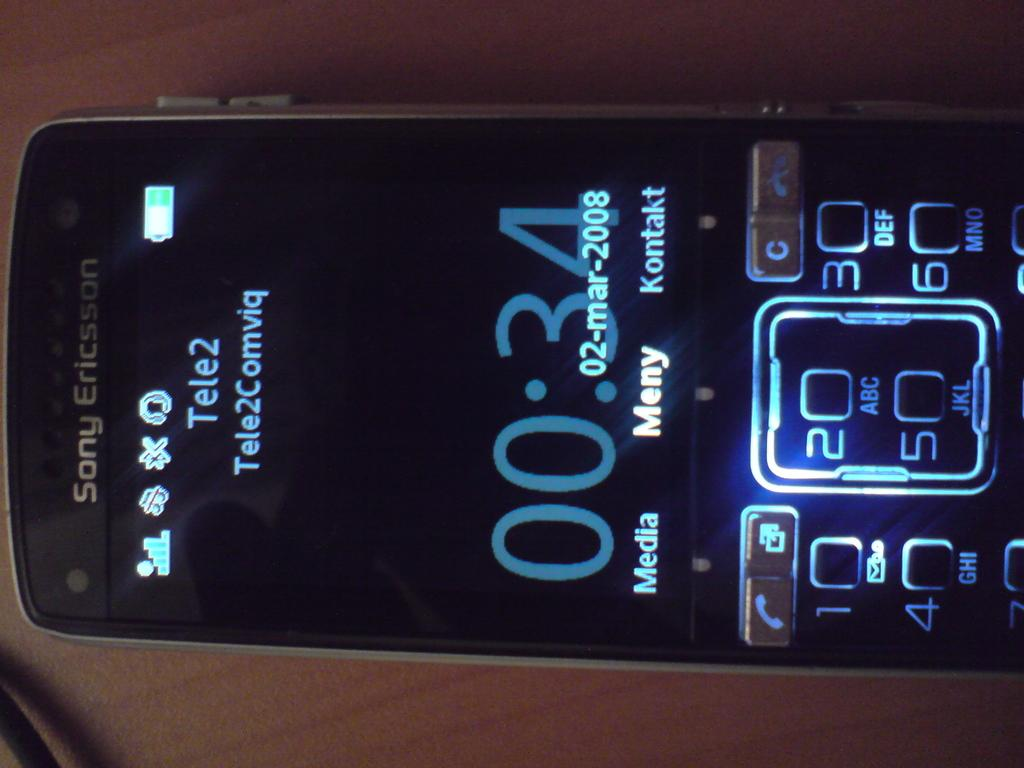<image>
Offer a succinct explanation of the picture presented. Sony Ericsson shows a 34 second call on this phone. 